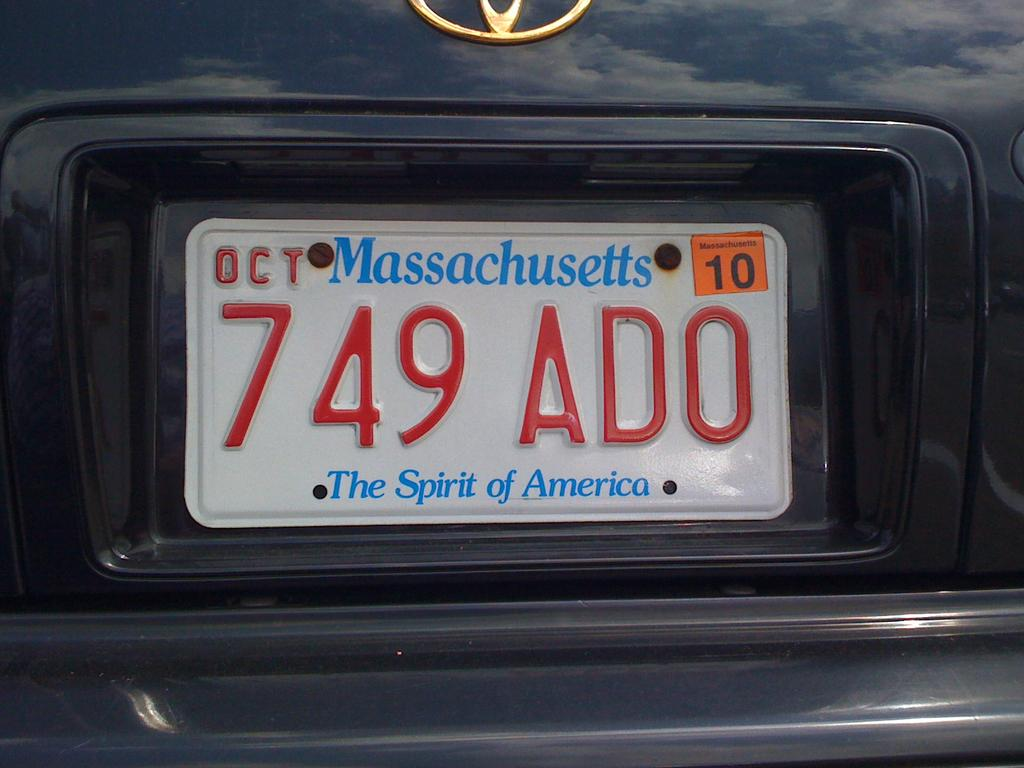Provide a one-sentence caption for the provided image. massachusetts car with license plates that reads 749ado. 